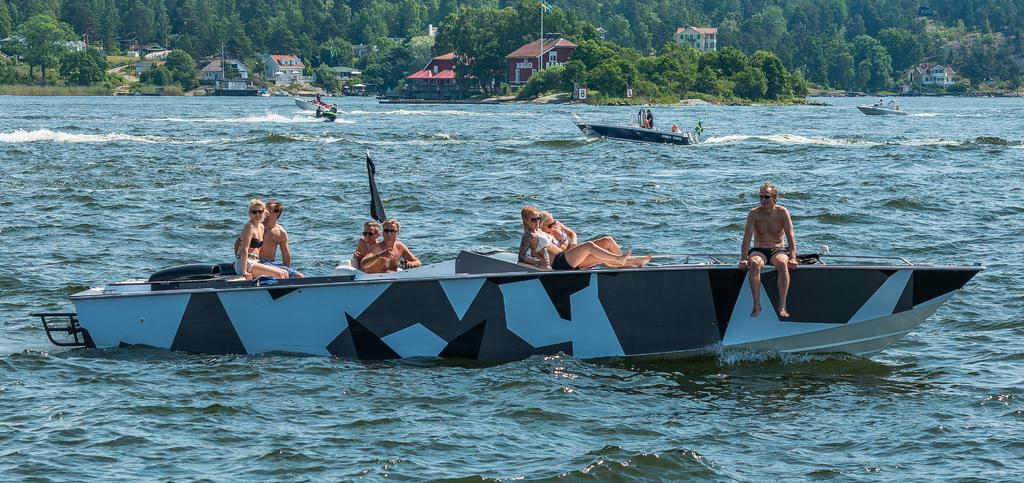What can be seen in the background of the image? In the background of the image, there are trees, a flag, and houses. What type of watercraft can be seen in the image? There are boats in the image. What is the color of the flag in the image? The flag in the image is black. What is the primary element visible in the image? Water is visible in the image. Are there any people present in the image? Yes, there are people in the image. What type of metal is used to make the wax sculptures in the image? There are no wax sculptures present in the image, so it is not possible to determine the type of metal used. What type of harbor can be seen in the image? There is no harbor present in the image; it features boats on water with a background of trees, a flag, and houses. 